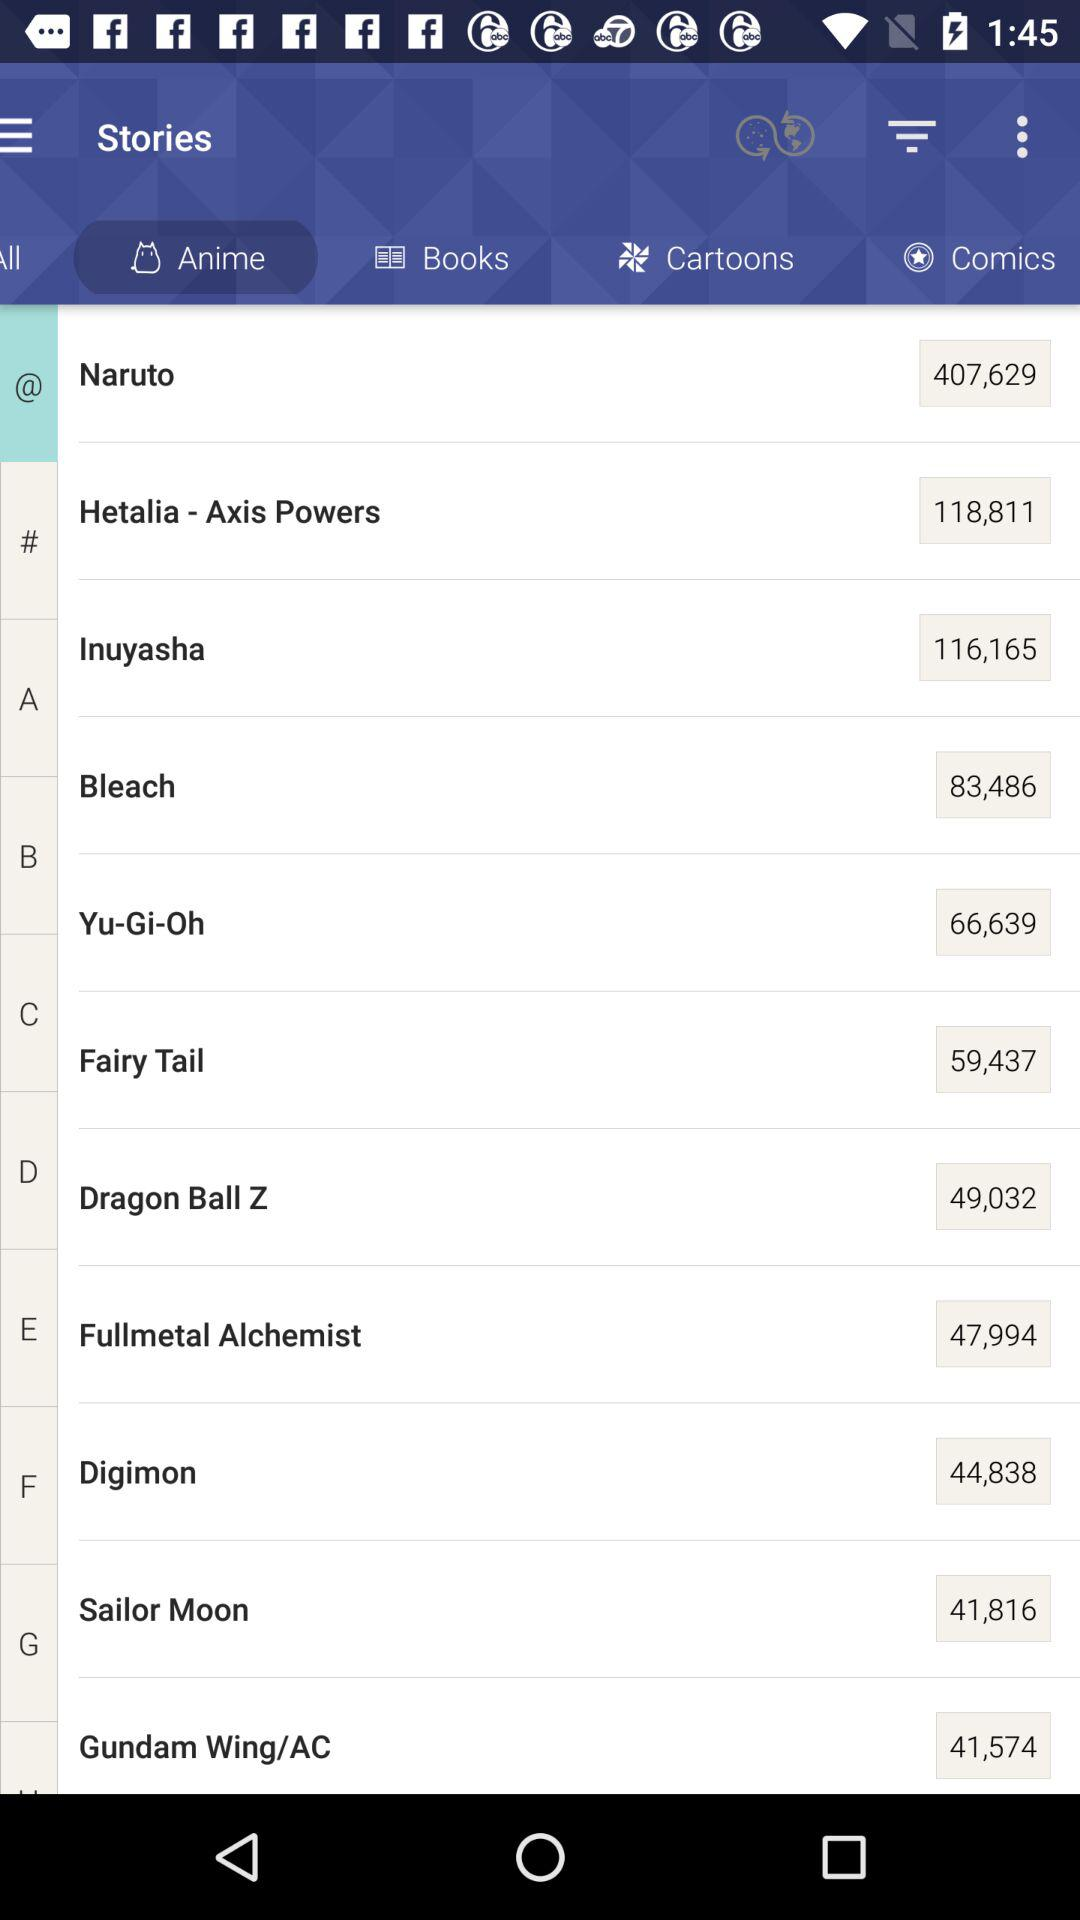What are the names of the anime? The names of the anime are "Naruto", "Hetalia-Axis Powers", "Inuyasha", "Bleach", "Yu-Gi-oh", "Fairy Tail", "Dragon Ball Z", "Fullmetal Alchemist", "Digimon", "Sailor Moon", and "Gundam Wing/AC". 